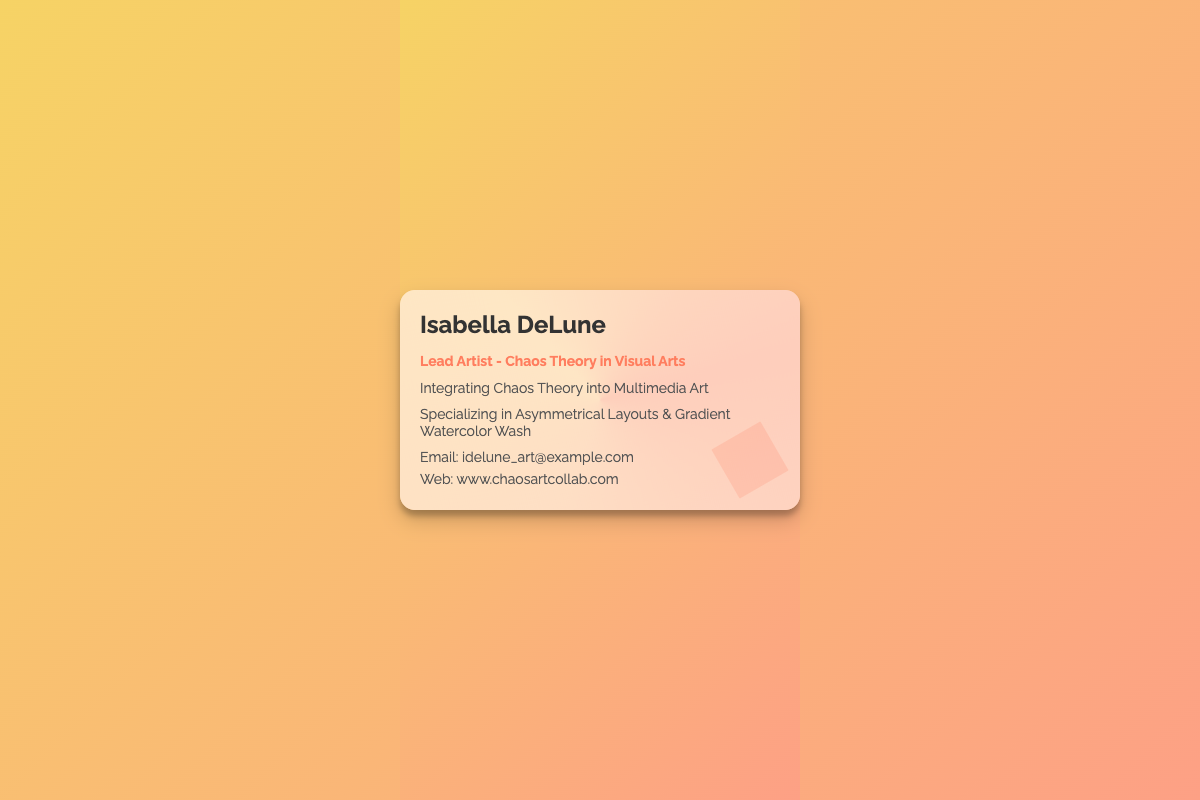what is the name of the artist? The artist's name is prominently displayed at the top of the card.
Answer: Isabella DeLune what is the artist's title? The title is outlined beneath the name, indicating the artist's role.
Answer: Lead Artist - Chaos Theory in Visual Arts what is the main focus of the artist's work? The main focus is specified in a line detailing their artistic integration.
Answer: Integrating Chaos Theory into Multimedia Art how can you contact the artist via email? The email address is provided in the contact section of the card.
Answer: idelune_art@example.com what design style is emphasized in the document? The document highlights specific design styles related to the artist's work.
Answer: Asymmetrical Layouts & Gradient Watercolor Wash what is the website for the artist's work? The website is listed in the contact information at the bottom.
Answer: www.chaosartcollab.com 